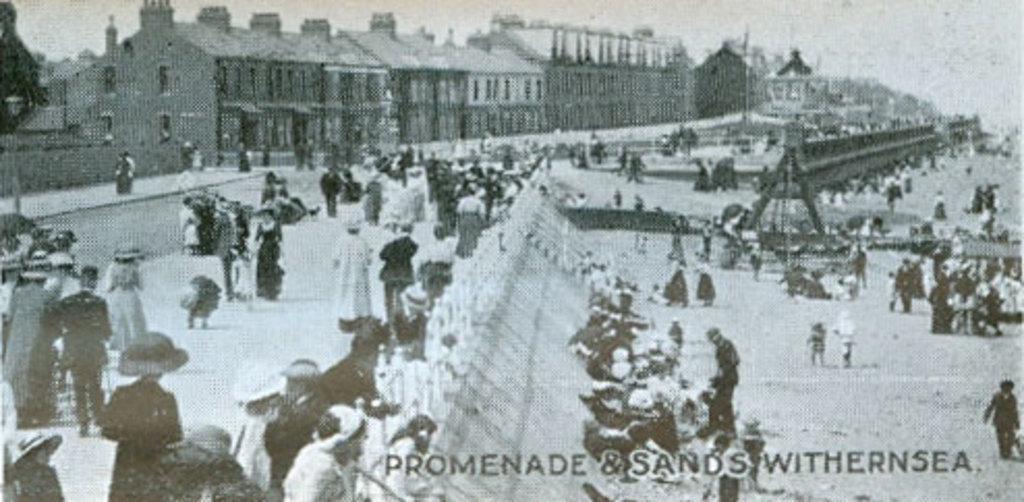Can you describe this image briefly? This is a black and white image. There are some persons in the middle. 